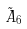Convert formula to latex. <formula><loc_0><loc_0><loc_500><loc_500>\tilde { A } _ { 6 }</formula> 